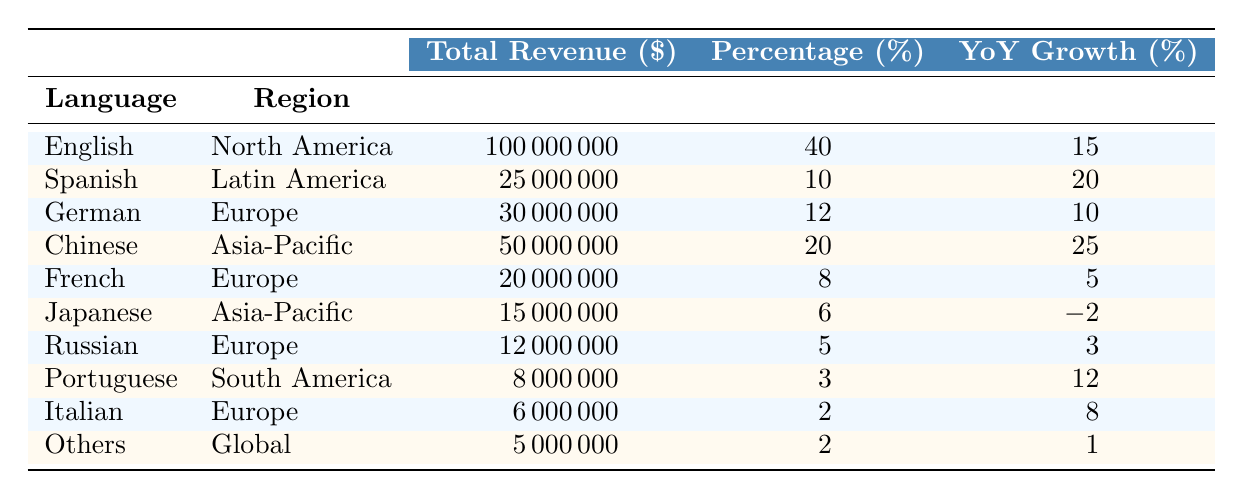What language generated the highest total revenue? Referring to the table, English has the highest revenue at $100,000,000.
Answer: English What is the percentage of total revenue generated by French language support? The table states that French generated 8% of the total revenue.
Answer: 8% Which region contributed the least to the revenue breakdown? Portuguese from South America contributed the least with $8,000,000 in total revenue.
Answer: South America What is the year-on-year growth percentage for Japanese language support? The table indicates that Japanese had a year-on-year growth of -2%.
Answer: -2% What is the total revenue generated by all languages in Europe? Summing the revenues for German ($30,000,000), French ($20,000,000), Russian ($12,000,000), and Italian ($6,000,000) gives $68,000,000.
Answer: $68,000,000 Is the total revenue percentage for Spanish language support greater than the total revenue percentage for French? Spanish accounts for 10% while French accounts for 8%, so yes, it is true that Spanish has a higher percentage.
Answer: Yes Which language had the highest year-on-year growth in total revenue, and what was its growth percentage? Looking at the table, Chinese had the highest growth at 25%.
Answer: Chinese, 25% If we add the total revenues from all the Asia-Pacific regions, what would it be? Adding Chinese ($50,000,000) and Japanese ($15,000,000), the total revenue is $65,000,000.
Answer: $65,000,000 What percentage of revenue does the "Others" category represent? "Others" represents 2% of the total revenue according to the table.
Answer: 2% Which language supported in e-commerce applications experienced a decline in revenue growth, and what was that growth rate? Japanese is the only language with a negative growth rate of -2%.
Answer: Japanese, -2% 